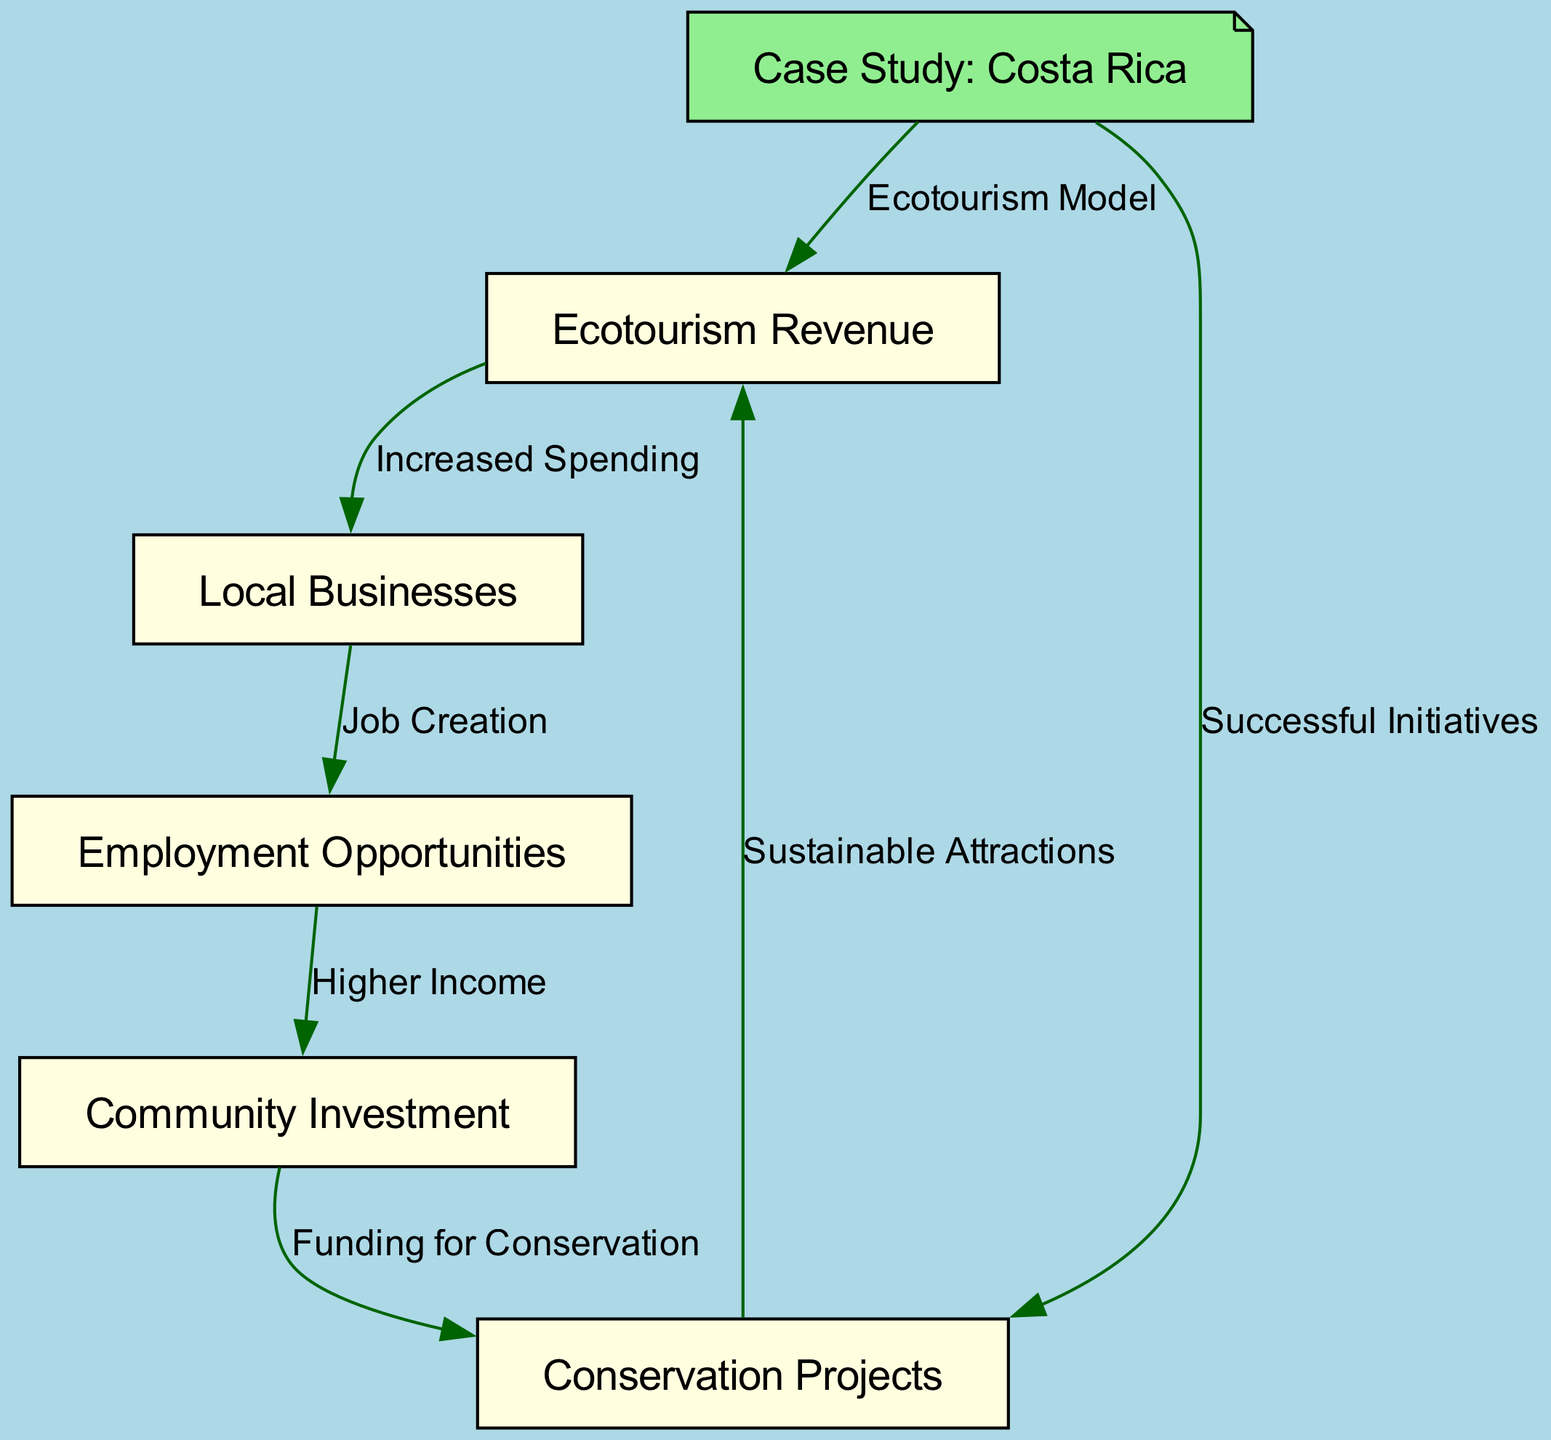What is the main source of revenue in the diagram? The main source of revenue is indicated by the node labeled "Ecotourism Revenue." This node sits at the starting point of the flowchart and connects to local businesses, highlighting its importance as the initial revenue source.
Answer: Ecotourism Revenue How many nodes are present in the diagram? By counting the nodes listed in the data, we find that there are six nodes in total: Ecotourism Revenue, Local Businesses, Employment Opportunities, Community Investment, Conservation Projects, and Case Study: Costa Rica.
Answer: 6 What relationship exists between "Local Businesses" and "Employment Opportunities"? The relationship is described by the edge labeled "Job Creation," indicating that local businesses benefit from ecotourism revenue by creating jobs for the community.
Answer: Job Creation What contributes to "Funding for Conservation"? "Funding for Conservation" comes from "Community Investment," which is fed by "Higher Income" derived from "Employment Opportunities." This relationship shows how increased employment can lead to greater community financial support for conservation efforts.
Answer: Community Investment Which case study is referenced, and what does it contribute to? The case study referenced is "Case Study: Costa Rica," which contributes to both "Conservation Projects" through successful initiatives and "Ecotourism Revenue" by exemplifying an effective ecotourism model.
Answer: Case Study: Costa Rica What is the result of "Higher Income" in this flowchart? "Higher Income" results in "Community Investment," connecting personal financial gain to wider community benefits and allowing for funding of projects, including conservation efforts.
Answer: Community Investment How does "Conservation Projects" impact "Ecotourism Revenue"? "Conservation Projects" impact "Ecotourism Revenue" positively by providing "Sustainable Attractions," which can draw more visitors and, therefore, generate higher ecotourism revenue.
Answer: Sustainable Attractions What leads to "Job Creation"? "Job Creation" is directly led by "Local Businesses," which thrive on increased ecotourism revenue that allows them to hire more staff and expand operations.
Answer: Local Businesses 